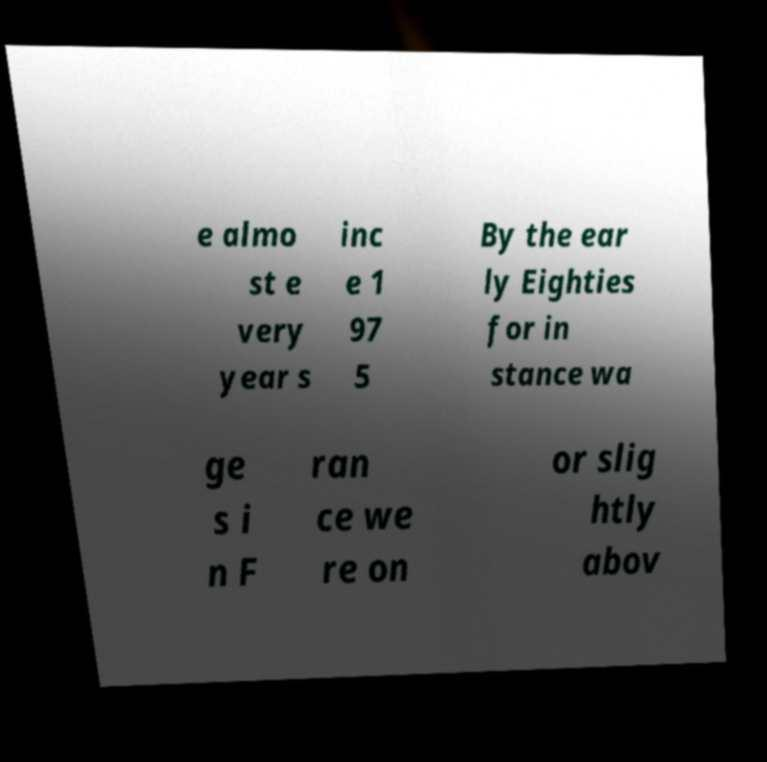I need the written content from this picture converted into text. Can you do that? e almo st e very year s inc e 1 97 5 By the ear ly Eighties for in stance wa ge s i n F ran ce we re on or slig htly abov 